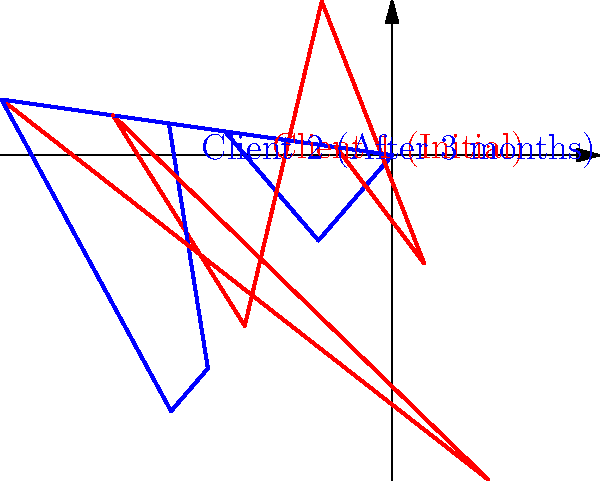The polar plot shows the flexibility measurements of two clients at different body angles. Client 1's data (red) represents initial measurements, while Client 2's data (blue) shows measurements after 3 months of training. At which angle(s) did Client 2 show the most improvement in flexibility compared to Client 1? To determine at which angle(s) Client 2 showed the most improvement, we need to compare the measurements for both clients at each angle:

1. 0°: Client 1 = 4, Client 2 = 3 (No improvement)
2. 45°: Client 1 = 3, Client 2 = 4 (Improvement of 1)
3. 90°: Client 1 = 5, Client 2 = 4 (No improvement)
4. 135°: Client 1 = 2, Client 2 = 3 (Improvement of 1)
5. 180°: Client 1 = 4, Client 2 = 3 (No improvement)
6. 225°: Client 1 = 3, Client 2 = 4 (Improvement of 1)
7. 270°: Client 1 = 5, Client 2 = 4 (No improvement)
8. 315°: Client 1 = 3, Client 2 = 3 (No improvement)

The maximum improvement is 1 unit, which occurs at three angles: 45°, 135°, and 225°.
Answer: 45°, 135°, and 225° 